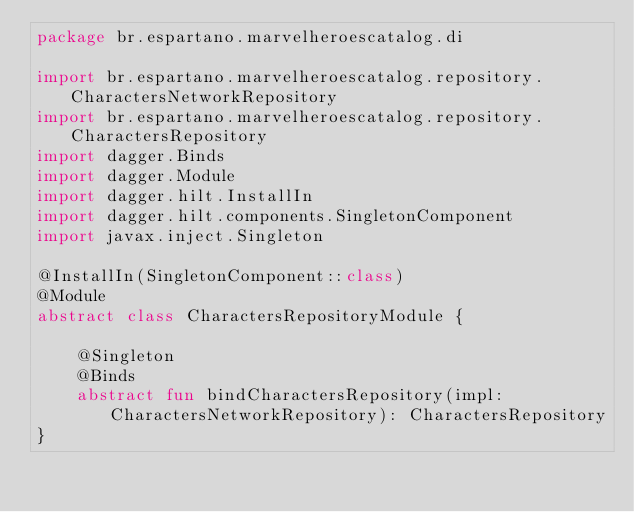<code> <loc_0><loc_0><loc_500><loc_500><_Kotlin_>package br.espartano.marvelheroescatalog.di

import br.espartano.marvelheroescatalog.repository.CharactersNetworkRepository
import br.espartano.marvelheroescatalog.repository.CharactersRepository
import dagger.Binds
import dagger.Module
import dagger.hilt.InstallIn
import dagger.hilt.components.SingletonComponent
import javax.inject.Singleton

@InstallIn(SingletonComponent::class)
@Module
abstract class CharactersRepositoryModule {

    @Singleton
    @Binds
    abstract fun bindCharactersRepository(impl: CharactersNetworkRepository): CharactersRepository
}</code> 